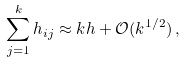<formula> <loc_0><loc_0><loc_500><loc_500>\sum _ { j = 1 } ^ { k } h _ { i j } \approx k h + \mathcal { O } ( k ^ { 1 / 2 } ) \, ,</formula> 